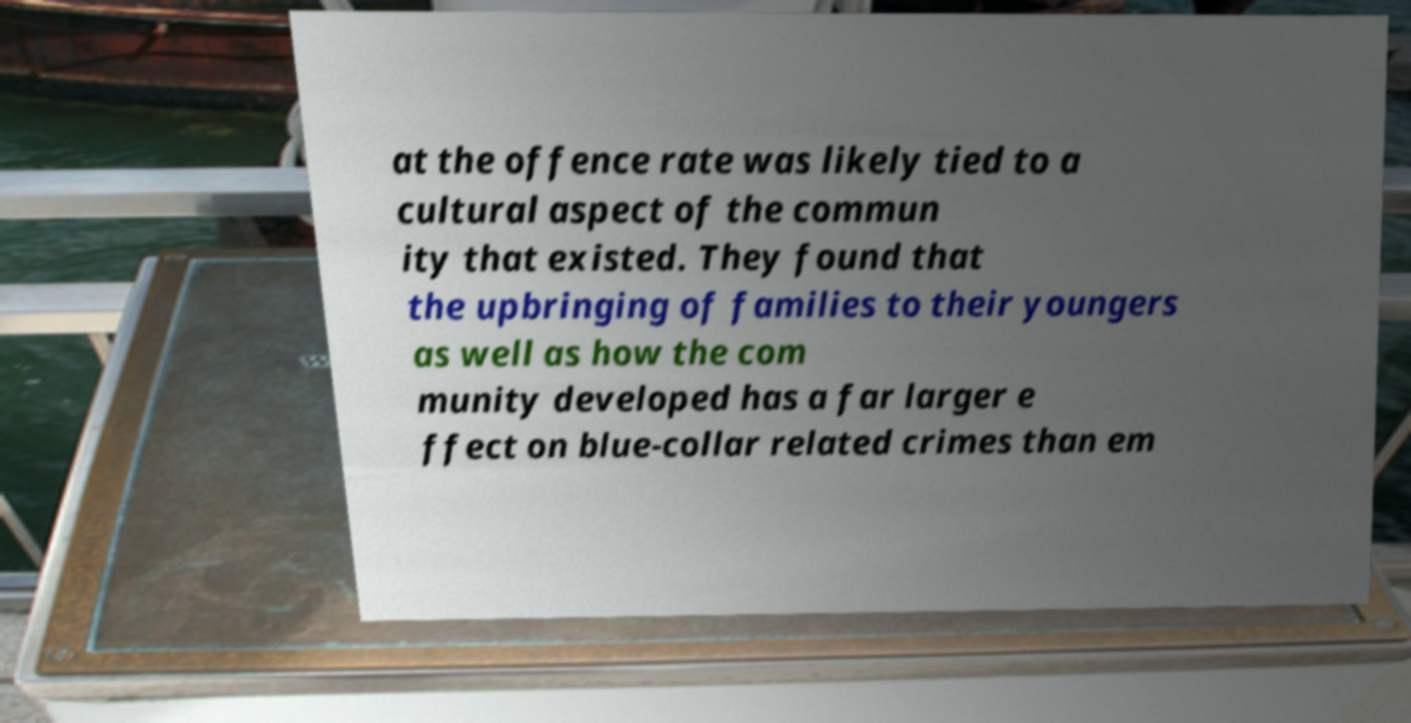Can you read and provide the text displayed in the image?This photo seems to have some interesting text. Can you extract and type it out for me? at the offence rate was likely tied to a cultural aspect of the commun ity that existed. They found that the upbringing of families to their youngers as well as how the com munity developed has a far larger e ffect on blue-collar related crimes than em 